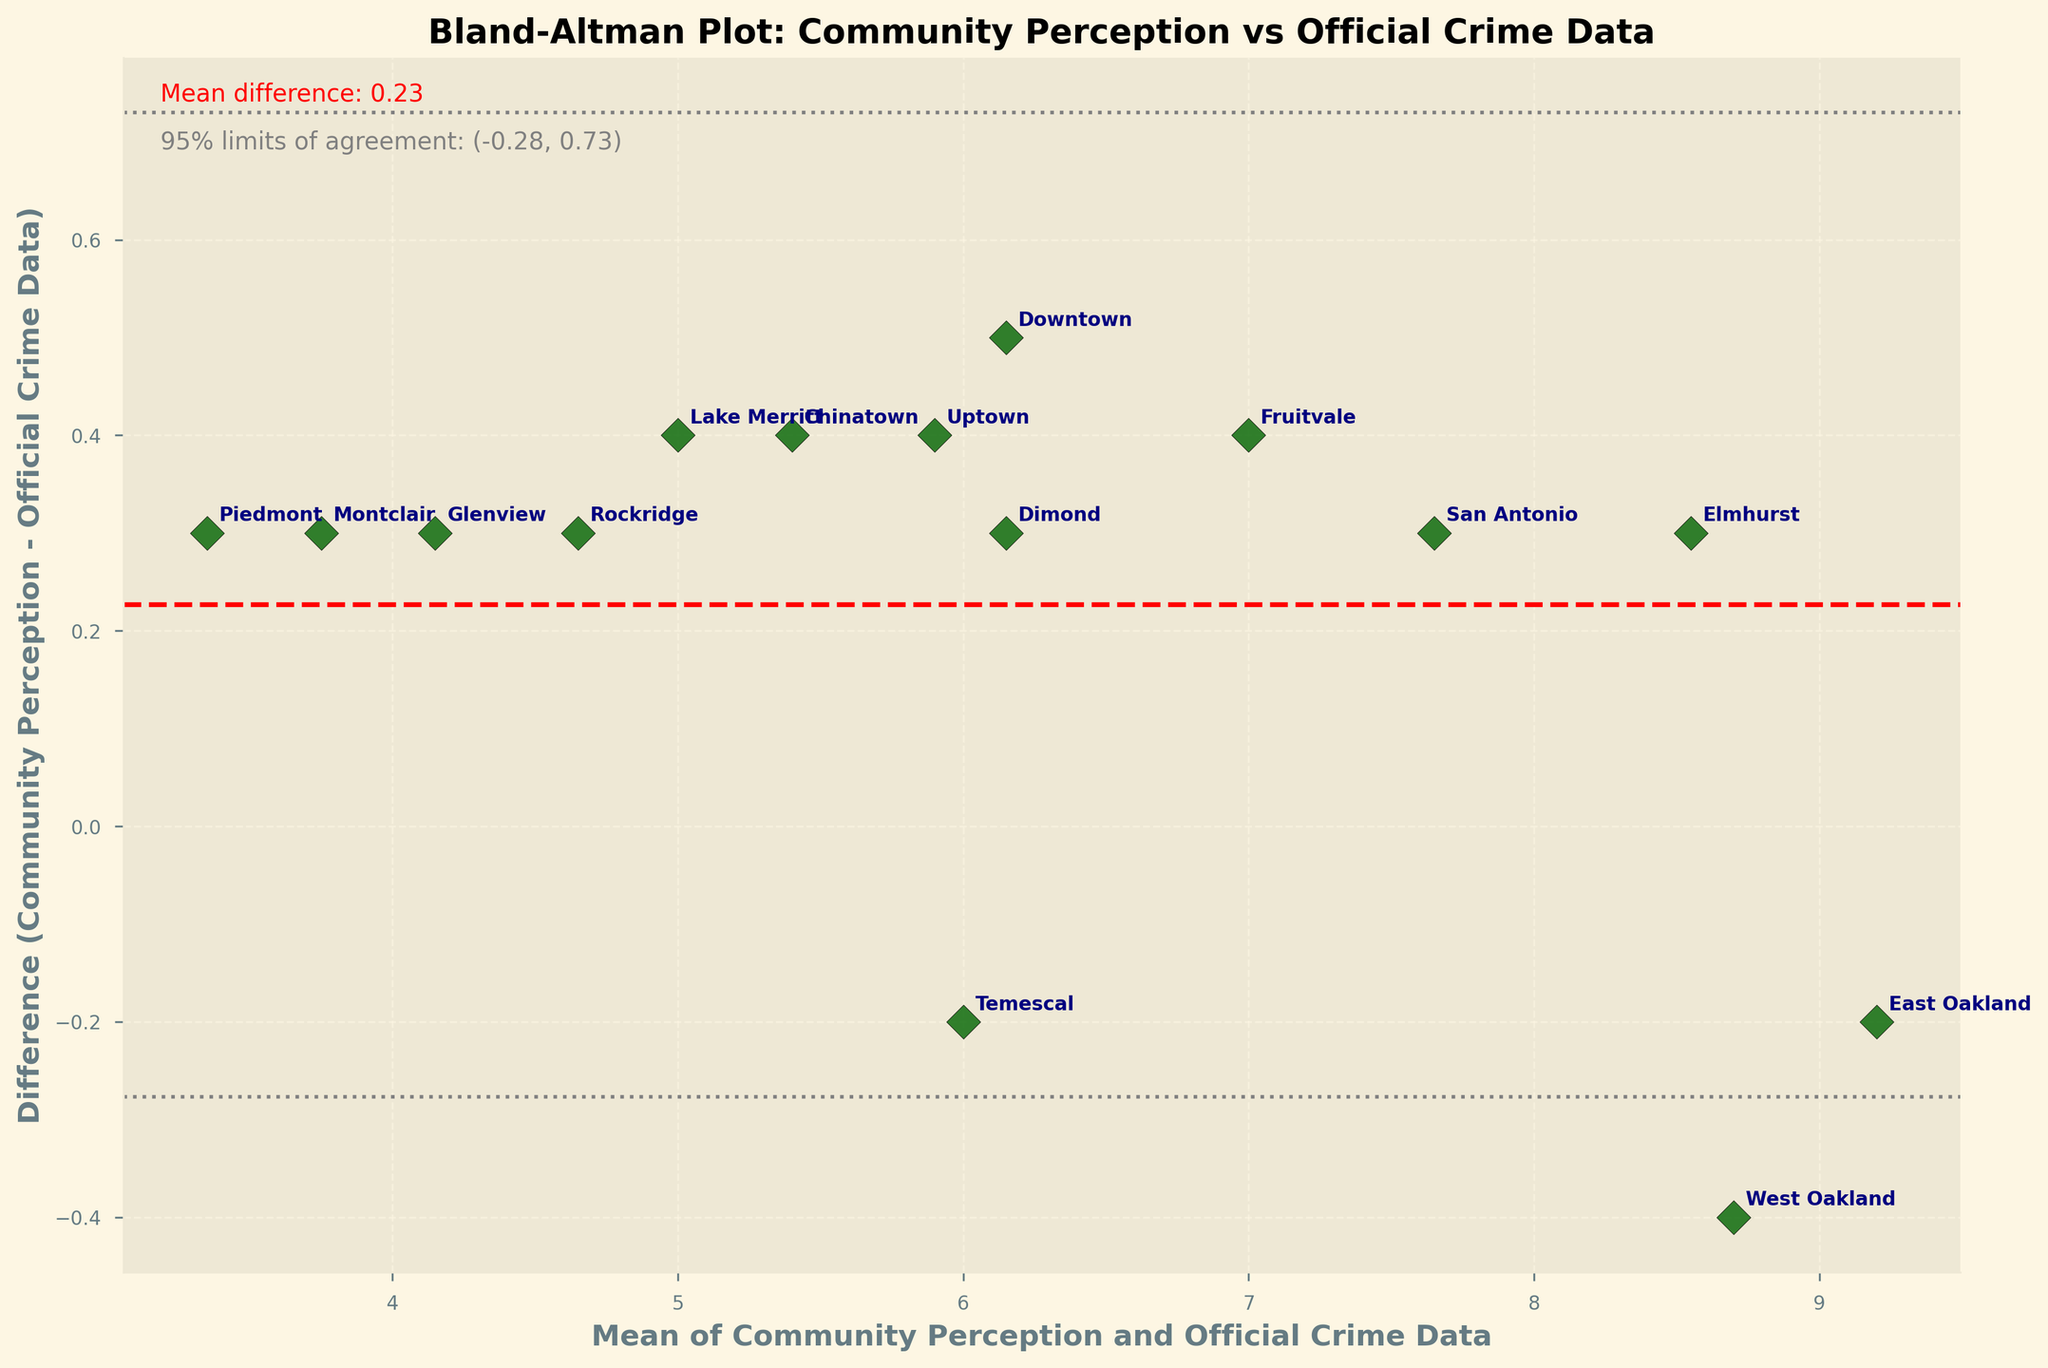What's the title of the plot? The title can be found at the top of the plot. It reads "Bland-Altman Plot: Community Perception vs Official Crime Data".
Answer: Bland-Altman Plot: Community Perception vs Official Crime Data How many data points are represented in the plot? Count the number of plotted points, each representing a different district in the dataset. There are 15 districts listed in the data.
Answer: 15 What is the mean difference between Community Perception and Official Crime Data? The mean difference is shown by a horizontal line and indicated in the text on the plot. The text reads "Mean difference: -0.17".
Answer: -0.17 What do the dashed gray lines represent? The dashed gray lines indicate the 95% limits of agreement. These are shown as "+1.96*sd" and "-1.96*sd". The exact values are given in the text as "( -0.95, 0.61 )".
Answer: 95% limits of agreement Which district has the largest positive difference between Community Perception and Official Crime Data? Look for the point highest above the horizontal line where the difference is zero. "Uptown" appears higher above this line compared to others, indicating it has the largest positive difference.
Answer: Uptown Which district has the largest negative difference between Community Perception and Official Crime Data? Identify the point lowest below the horizontal reference line. "Lake Merritt" is the lowest, signifying the largest negative difference.
Answer: Lake Merritt What does the x-axis represent? The x-axis label indicates it represents the "Mean of Community Perception and Official Crime Data".
Answer: Mean of Community Perception and Official Crime Data Is there any district where Community Perception equals Official Crime Data? Look for a point exactly on the zero difference line. There is no point on the line, so no district has identical values.
Answer: No Which district has a mean value of around 7.0 on the x-axis? Locate the mean value around 7.0 on the x-axis and find the annotated district near that point. "Fruitvale" is close to a mean of 7.0.
Answer: Fruitvale What is the standard deviation of the differences? The standard deviation can be inferred from the plotted limits of agreement lines. Since the limits are labeled as "95% limits of agreement: ( -0.95, 0.61 )" and using the formula `Mean ± 1.96*SD`, solving for SD gives (0.61 - (-0.95))/3.92 which approximates to "0.40". This value is not explicitly stated but can be derived.
Answer: 0.40 